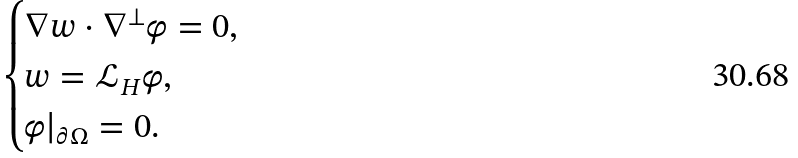<formula> <loc_0><loc_0><loc_500><loc_500>\begin{cases} \nabla w \cdot \nabla ^ { \perp } \varphi = 0 , \\ w = \mathcal { L } _ { H } \varphi , \\ \varphi | _ { \partial \Omega } = 0 . \end{cases}</formula> 